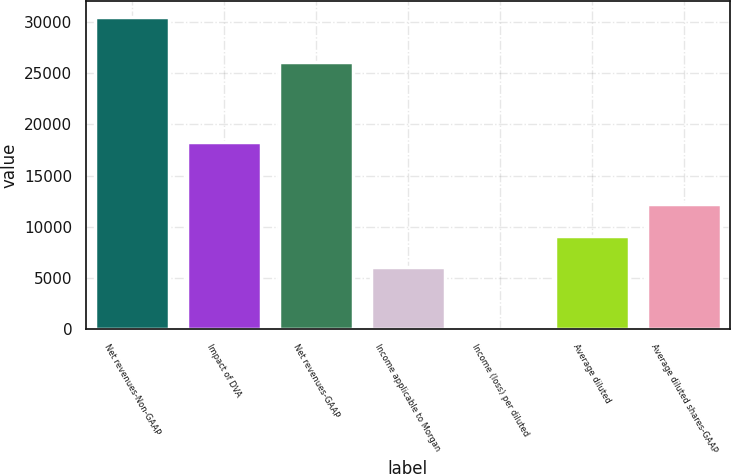<chart> <loc_0><loc_0><loc_500><loc_500><bar_chart><fcel>Net revenues-Non-GAAP<fcel>Impact of DVA<fcel>Net revenues-GAAP<fcel>Income applicable to Morgan<fcel>Income (loss) per diluted<fcel>Average diluted<fcel>Average diluted shares-GAAP<nl><fcel>30514<fcel>18308.4<fcel>26112<fcel>6102.82<fcel>0.02<fcel>9154.22<fcel>12205.6<nl></chart> 